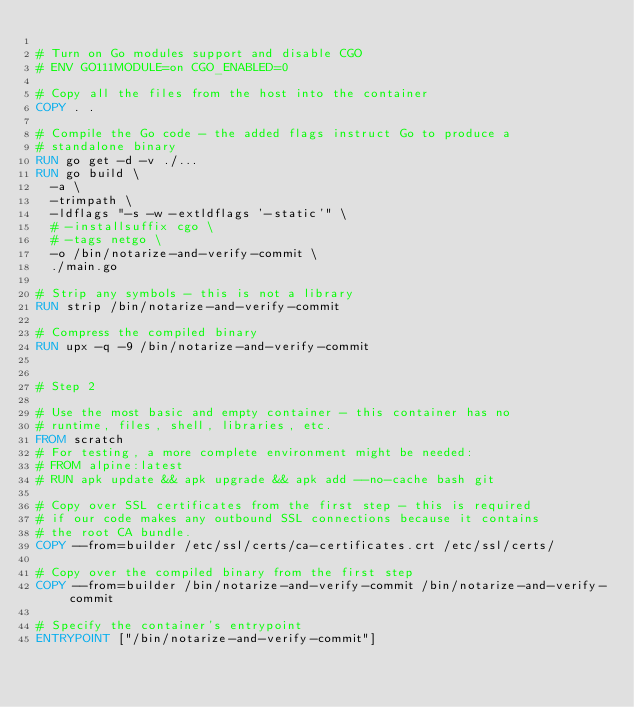<code> <loc_0><loc_0><loc_500><loc_500><_Dockerfile_>
# Turn on Go modules support and disable CGO
# ENV GO111MODULE=on CGO_ENABLED=0

# Copy all the files from the host into the container
COPY . .

# Compile the Go code - the added flags instruct Go to produce a
# standalone binary
RUN go get -d -v ./...
RUN go build \
  -a \
  -trimpath \
  -ldflags "-s -w -extldflags '-static'" \
  # -installsuffix cgo \
  # -tags netgo \
  -o /bin/notarize-and-verify-commit \
  ./main.go

# Strip any symbols - this is not a library
RUN strip /bin/notarize-and-verify-commit

# Compress the compiled binary
RUN upx -q -9 /bin/notarize-and-verify-commit


# Step 2

# Use the most basic and empty container - this container has no
# runtime, files, shell, libraries, etc.
FROM scratch
# For testing, a more complete environment might be needed:
# FROM alpine:latest
# RUN apk update && apk upgrade && apk add --no-cache bash git

# Copy over SSL certificates from the first step - this is required
# if our code makes any outbound SSL connections because it contains
# the root CA bundle.
COPY --from=builder /etc/ssl/certs/ca-certificates.crt /etc/ssl/certs/

# Copy over the compiled binary from the first step
COPY --from=builder /bin/notarize-and-verify-commit /bin/notarize-and-verify-commit

# Specify the container's entrypoint
ENTRYPOINT ["/bin/notarize-and-verify-commit"]</code> 